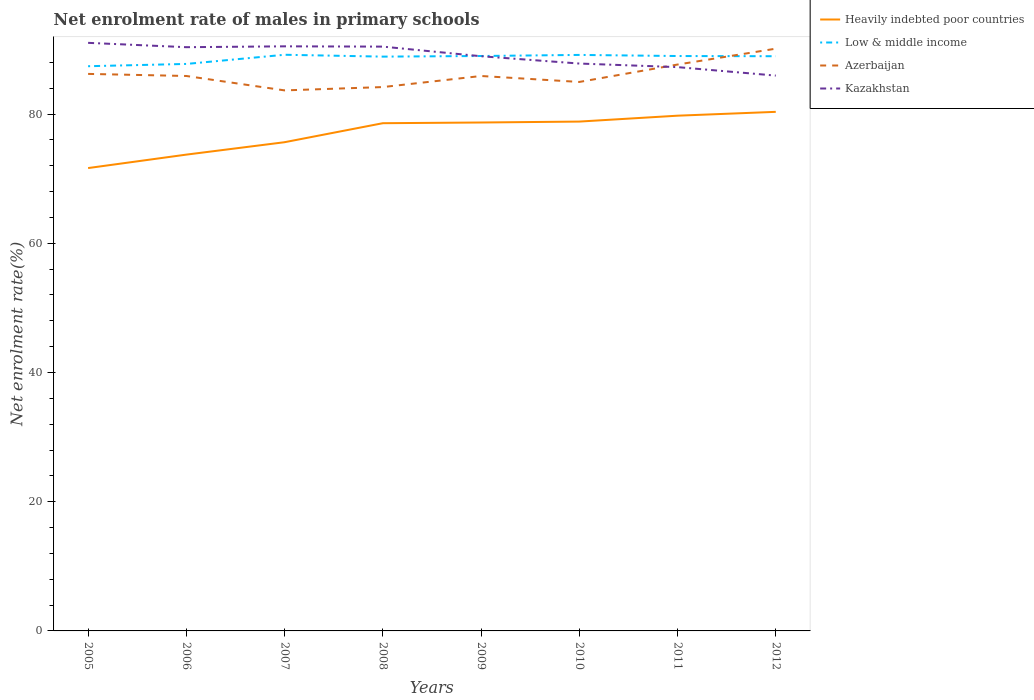How many different coloured lines are there?
Offer a very short reply. 4. Is the number of lines equal to the number of legend labels?
Keep it short and to the point. Yes. Across all years, what is the maximum net enrolment rate of males in primary schools in Azerbaijan?
Your response must be concise. 83.67. In which year was the net enrolment rate of males in primary schools in Kazakhstan maximum?
Your answer should be very brief. 2012. What is the total net enrolment rate of males in primary schools in Kazakhstan in the graph?
Make the answer very short. -0.13. What is the difference between the highest and the second highest net enrolment rate of males in primary schools in Heavily indebted poor countries?
Offer a very short reply. 8.7. What is the difference between the highest and the lowest net enrolment rate of males in primary schools in Kazakhstan?
Offer a very short reply. 4. Is the net enrolment rate of males in primary schools in Low & middle income strictly greater than the net enrolment rate of males in primary schools in Azerbaijan over the years?
Your answer should be compact. No. How many lines are there?
Offer a terse response. 4. How many years are there in the graph?
Keep it short and to the point. 8. What is the difference between two consecutive major ticks on the Y-axis?
Make the answer very short. 20. Are the values on the major ticks of Y-axis written in scientific E-notation?
Provide a succinct answer. No. Does the graph contain any zero values?
Ensure brevity in your answer.  No. How many legend labels are there?
Make the answer very short. 4. What is the title of the graph?
Provide a succinct answer. Net enrolment rate of males in primary schools. Does "Cyprus" appear as one of the legend labels in the graph?
Provide a short and direct response. No. What is the label or title of the Y-axis?
Your answer should be compact. Net enrolment rate(%). What is the Net enrolment rate(%) in Heavily indebted poor countries in 2005?
Your response must be concise. 71.64. What is the Net enrolment rate(%) in Low & middle income in 2005?
Your answer should be compact. 87.41. What is the Net enrolment rate(%) in Azerbaijan in 2005?
Keep it short and to the point. 86.22. What is the Net enrolment rate(%) in Kazakhstan in 2005?
Provide a succinct answer. 91.03. What is the Net enrolment rate(%) in Heavily indebted poor countries in 2006?
Your answer should be very brief. 73.72. What is the Net enrolment rate(%) in Low & middle income in 2006?
Keep it short and to the point. 87.76. What is the Net enrolment rate(%) in Azerbaijan in 2006?
Provide a short and direct response. 85.89. What is the Net enrolment rate(%) in Kazakhstan in 2006?
Provide a succinct answer. 90.35. What is the Net enrolment rate(%) of Heavily indebted poor countries in 2007?
Your response must be concise. 75.65. What is the Net enrolment rate(%) in Low & middle income in 2007?
Ensure brevity in your answer.  89.18. What is the Net enrolment rate(%) in Azerbaijan in 2007?
Your answer should be very brief. 83.67. What is the Net enrolment rate(%) in Kazakhstan in 2007?
Ensure brevity in your answer.  90.48. What is the Net enrolment rate(%) in Heavily indebted poor countries in 2008?
Offer a very short reply. 78.59. What is the Net enrolment rate(%) in Low & middle income in 2008?
Make the answer very short. 88.89. What is the Net enrolment rate(%) of Azerbaijan in 2008?
Keep it short and to the point. 84.18. What is the Net enrolment rate(%) in Kazakhstan in 2008?
Offer a terse response. 90.44. What is the Net enrolment rate(%) of Heavily indebted poor countries in 2009?
Ensure brevity in your answer.  78.7. What is the Net enrolment rate(%) of Low & middle income in 2009?
Keep it short and to the point. 88.99. What is the Net enrolment rate(%) in Azerbaijan in 2009?
Your response must be concise. 85.89. What is the Net enrolment rate(%) in Kazakhstan in 2009?
Offer a very short reply. 88.95. What is the Net enrolment rate(%) in Heavily indebted poor countries in 2010?
Your response must be concise. 78.84. What is the Net enrolment rate(%) in Low & middle income in 2010?
Your answer should be compact. 89.16. What is the Net enrolment rate(%) in Azerbaijan in 2010?
Offer a very short reply. 84.97. What is the Net enrolment rate(%) in Kazakhstan in 2010?
Provide a short and direct response. 87.82. What is the Net enrolment rate(%) in Heavily indebted poor countries in 2011?
Your answer should be compact. 79.75. What is the Net enrolment rate(%) of Low & middle income in 2011?
Your answer should be very brief. 88.98. What is the Net enrolment rate(%) in Azerbaijan in 2011?
Offer a terse response. 87.66. What is the Net enrolment rate(%) of Kazakhstan in 2011?
Your answer should be compact. 87.27. What is the Net enrolment rate(%) in Heavily indebted poor countries in 2012?
Ensure brevity in your answer.  80.34. What is the Net enrolment rate(%) of Low & middle income in 2012?
Provide a short and direct response. 88.95. What is the Net enrolment rate(%) in Azerbaijan in 2012?
Provide a short and direct response. 90.12. What is the Net enrolment rate(%) in Kazakhstan in 2012?
Give a very brief answer. 85.96. Across all years, what is the maximum Net enrolment rate(%) in Heavily indebted poor countries?
Make the answer very short. 80.34. Across all years, what is the maximum Net enrolment rate(%) in Low & middle income?
Give a very brief answer. 89.18. Across all years, what is the maximum Net enrolment rate(%) of Azerbaijan?
Offer a very short reply. 90.12. Across all years, what is the maximum Net enrolment rate(%) in Kazakhstan?
Make the answer very short. 91.03. Across all years, what is the minimum Net enrolment rate(%) of Heavily indebted poor countries?
Ensure brevity in your answer.  71.64. Across all years, what is the minimum Net enrolment rate(%) of Low & middle income?
Keep it short and to the point. 87.41. Across all years, what is the minimum Net enrolment rate(%) in Azerbaijan?
Ensure brevity in your answer.  83.67. Across all years, what is the minimum Net enrolment rate(%) of Kazakhstan?
Ensure brevity in your answer.  85.96. What is the total Net enrolment rate(%) of Heavily indebted poor countries in the graph?
Your answer should be very brief. 617.22. What is the total Net enrolment rate(%) of Low & middle income in the graph?
Your answer should be very brief. 709.32. What is the total Net enrolment rate(%) in Azerbaijan in the graph?
Your answer should be compact. 688.61. What is the total Net enrolment rate(%) in Kazakhstan in the graph?
Make the answer very short. 712.3. What is the difference between the Net enrolment rate(%) of Heavily indebted poor countries in 2005 and that in 2006?
Provide a short and direct response. -2.08. What is the difference between the Net enrolment rate(%) in Low & middle income in 2005 and that in 2006?
Your answer should be compact. -0.35. What is the difference between the Net enrolment rate(%) of Azerbaijan in 2005 and that in 2006?
Your response must be concise. 0.32. What is the difference between the Net enrolment rate(%) in Kazakhstan in 2005 and that in 2006?
Provide a succinct answer. 0.67. What is the difference between the Net enrolment rate(%) of Heavily indebted poor countries in 2005 and that in 2007?
Your response must be concise. -4. What is the difference between the Net enrolment rate(%) of Low & middle income in 2005 and that in 2007?
Your response must be concise. -1.77. What is the difference between the Net enrolment rate(%) in Azerbaijan in 2005 and that in 2007?
Keep it short and to the point. 2.55. What is the difference between the Net enrolment rate(%) of Kazakhstan in 2005 and that in 2007?
Ensure brevity in your answer.  0.54. What is the difference between the Net enrolment rate(%) in Heavily indebted poor countries in 2005 and that in 2008?
Offer a very short reply. -6.95. What is the difference between the Net enrolment rate(%) in Low & middle income in 2005 and that in 2008?
Keep it short and to the point. -1.49. What is the difference between the Net enrolment rate(%) of Azerbaijan in 2005 and that in 2008?
Keep it short and to the point. 2.04. What is the difference between the Net enrolment rate(%) in Kazakhstan in 2005 and that in 2008?
Provide a succinct answer. 0.59. What is the difference between the Net enrolment rate(%) in Heavily indebted poor countries in 2005 and that in 2009?
Your response must be concise. -7.05. What is the difference between the Net enrolment rate(%) of Low & middle income in 2005 and that in 2009?
Your answer should be very brief. -1.58. What is the difference between the Net enrolment rate(%) in Azerbaijan in 2005 and that in 2009?
Offer a terse response. 0.32. What is the difference between the Net enrolment rate(%) in Kazakhstan in 2005 and that in 2009?
Provide a succinct answer. 2.07. What is the difference between the Net enrolment rate(%) in Heavily indebted poor countries in 2005 and that in 2010?
Keep it short and to the point. -7.2. What is the difference between the Net enrolment rate(%) of Low & middle income in 2005 and that in 2010?
Offer a terse response. -1.75. What is the difference between the Net enrolment rate(%) in Azerbaijan in 2005 and that in 2010?
Give a very brief answer. 1.25. What is the difference between the Net enrolment rate(%) of Kazakhstan in 2005 and that in 2010?
Your answer should be very brief. 3.21. What is the difference between the Net enrolment rate(%) in Heavily indebted poor countries in 2005 and that in 2011?
Provide a short and direct response. -8.11. What is the difference between the Net enrolment rate(%) in Low & middle income in 2005 and that in 2011?
Your response must be concise. -1.58. What is the difference between the Net enrolment rate(%) in Azerbaijan in 2005 and that in 2011?
Keep it short and to the point. -1.45. What is the difference between the Net enrolment rate(%) of Kazakhstan in 2005 and that in 2011?
Ensure brevity in your answer.  3.76. What is the difference between the Net enrolment rate(%) of Heavily indebted poor countries in 2005 and that in 2012?
Your answer should be compact. -8.7. What is the difference between the Net enrolment rate(%) of Low & middle income in 2005 and that in 2012?
Ensure brevity in your answer.  -1.55. What is the difference between the Net enrolment rate(%) of Azerbaijan in 2005 and that in 2012?
Provide a short and direct response. -3.9. What is the difference between the Net enrolment rate(%) in Kazakhstan in 2005 and that in 2012?
Provide a succinct answer. 5.07. What is the difference between the Net enrolment rate(%) in Heavily indebted poor countries in 2006 and that in 2007?
Give a very brief answer. -1.92. What is the difference between the Net enrolment rate(%) of Low & middle income in 2006 and that in 2007?
Give a very brief answer. -1.42. What is the difference between the Net enrolment rate(%) in Azerbaijan in 2006 and that in 2007?
Provide a succinct answer. 2.23. What is the difference between the Net enrolment rate(%) of Kazakhstan in 2006 and that in 2007?
Provide a succinct answer. -0.13. What is the difference between the Net enrolment rate(%) of Heavily indebted poor countries in 2006 and that in 2008?
Offer a very short reply. -4.86. What is the difference between the Net enrolment rate(%) of Low & middle income in 2006 and that in 2008?
Offer a terse response. -1.13. What is the difference between the Net enrolment rate(%) in Azerbaijan in 2006 and that in 2008?
Give a very brief answer. 1.71. What is the difference between the Net enrolment rate(%) in Kazakhstan in 2006 and that in 2008?
Keep it short and to the point. -0.09. What is the difference between the Net enrolment rate(%) of Heavily indebted poor countries in 2006 and that in 2009?
Your answer should be compact. -4.97. What is the difference between the Net enrolment rate(%) in Low & middle income in 2006 and that in 2009?
Your response must be concise. -1.23. What is the difference between the Net enrolment rate(%) of Azerbaijan in 2006 and that in 2009?
Your answer should be compact. 0. What is the difference between the Net enrolment rate(%) of Kazakhstan in 2006 and that in 2009?
Offer a very short reply. 1.4. What is the difference between the Net enrolment rate(%) in Heavily indebted poor countries in 2006 and that in 2010?
Your response must be concise. -5.11. What is the difference between the Net enrolment rate(%) of Low & middle income in 2006 and that in 2010?
Make the answer very short. -1.4. What is the difference between the Net enrolment rate(%) of Azerbaijan in 2006 and that in 2010?
Your answer should be very brief. 0.92. What is the difference between the Net enrolment rate(%) in Kazakhstan in 2006 and that in 2010?
Ensure brevity in your answer.  2.53. What is the difference between the Net enrolment rate(%) of Heavily indebted poor countries in 2006 and that in 2011?
Offer a terse response. -6.03. What is the difference between the Net enrolment rate(%) in Low & middle income in 2006 and that in 2011?
Provide a succinct answer. -1.22. What is the difference between the Net enrolment rate(%) of Azerbaijan in 2006 and that in 2011?
Give a very brief answer. -1.77. What is the difference between the Net enrolment rate(%) of Kazakhstan in 2006 and that in 2011?
Keep it short and to the point. 3.09. What is the difference between the Net enrolment rate(%) of Heavily indebted poor countries in 2006 and that in 2012?
Give a very brief answer. -6.62. What is the difference between the Net enrolment rate(%) in Low & middle income in 2006 and that in 2012?
Offer a terse response. -1.19. What is the difference between the Net enrolment rate(%) in Azerbaijan in 2006 and that in 2012?
Your answer should be very brief. -4.23. What is the difference between the Net enrolment rate(%) in Kazakhstan in 2006 and that in 2012?
Your answer should be compact. 4.4. What is the difference between the Net enrolment rate(%) of Heavily indebted poor countries in 2007 and that in 2008?
Offer a very short reply. -2.94. What is the difference between the Net enrolment rate(%) in Low & middle income in 2007 and that in 2008?
Give a very brief answer. 0.29. What is the difference between the Net enrolment rate(%) in Azerbaijan in 2007 and that in 2008?
Your answer should be compact. -0.51. What is the difference between the Net enrolment rate(%) in Kazakhstan in 2007 and that in 2008?
Keep it short and to the point. 0.04. What is the difference between the Net enrolment rate(%) of Heavily indebted poor countries in 2007 and that in 2009?
Ensure brevity in your answer.  -3.05. What is the difference between the Net enrolment rate(%) of Low & middle income in 2007 and that in 2009?
Your answer should be very brief. 0.19. What is the difference between the Net enrolment rate(%) of Azerbaijan in 2007 and that in 2009?
Provide a short and direct response. -2.23. What is the difference between the Net enrolment rate(%) in Kazakhstan in 2007 and that in 2009?
Your response must be concise. 1.53. What is the difference between the Net enrolment rate(%) of Heavily indebted poor countries in 2007 and that in 2010?
Your answer should be very brief. -3.19. What is the difference between the Net enrolment rate(%) in Low & middle income in 2007 and that in 2010?
Your answer should be compact. 0.02. What is the difference between the Net enrolment rate(%) of Azerbaijan in 2007 and that in 2010?
Your response must be concise. -1.31. What is the difference between the Net enrolment rate(%) of Kazakhstan in 2007 and that in 2010?
Ensure brevity in your answer.  2.66. What is the difference between the Net enrolment rate(%) in Heavily indebted poor countries in 2007 and that in 2011?
Make the answer very short. -4.1. What is the difference between the Net enrolment rate(%) in Low & middle income in 2007 and that in 2011?
Keep it short and to the point. 0.2. What is the difference between the Net enrolment rate(%) in Azerbaijan in 2007 and that in 2011?
Ensure brevity in your answer.  -4. What is the difference between the Net enrolment rate(%) of Kazakhstan in 2007 and that in 2011?
Make the answer very short. 3.22. What is the difference between the Net enrolment rate(%) of Heavily indebted poor countries in 2007 and that in 2012?
Provide a succinct answer. -4.7. What is the difference between the Net enrolment rate(%) of Low & middle income in 2007 and that in 2012?
Make the answer very short. 0.23. What is the difference between the Net enrolment rate(%) of Azerbaijan in 2007 and that in 2012?
Keep it short and to the point. -6.46. What is the difference between the Net enrolment rate(%) of Kazakhstan in 2007 and that in 2012?
Give a very brief answer. 4.53. What is the difference between the Net enrolment rate(%) in Heavily indebted poor countries in 2008 and that in 2009?
Give a very brief answer. -0.11. What is the difference between the Net enrolment rate(%) of Low & middle income in 2008 and that in 2009?
Make the answer very short. -0.1. What is the difference between the Net enrolment rate(%) of Azerbaijan in 2008 and that in 2009?
Provide a succinct answer. -1.71. What is the difference between the Net enrolment rate(%) of Kazakhstan in 2008 and that in 2009?
Offer a terse response. 1.49. What is the difference between the Net enrolment rate(%) of Heavily indebted poor countries in 2008 and that in 2010?
Your answer should be compact. -0.25. What is the difference between the Net enrolment rate(%) of Low & middle income in 2008 and that in 2010?
Provide a short and direct response. -0.26. What is the difference between the Net enrolment rate(%) of Azerbaijan in 2008 and that in 2010?
Your response must be concise. -0.79. What is the difference between the Net enrolment rate(%) of Kazakhstan in 2008 and that in 2010?
Give a very brief answer. 2.62. What is the difference between the Net enrolment rate(%) of Heavily indebted poor countries in 2008 and that in 2011?
Provide a succinct answer. -1.16. What is the difference between the Net enrolment rate(%) in Low & middle income in 2008 and that in 2011?
Your answer should be compact. -0.09. What is the difference between the Net enrolment rate(%) in Azerbaijan in 2008 and that in 2011?
Provide a short and direct response. -3.48. What is the difference between the Net enrolment rate(%) of Kazakhstan in 2008 and that in 2011?
Your response must be concise. 3.17. What is the difference between the Net enrolment rate(%) in Heavily indebted poor countries in 2008 and that in 2012?
Offer a terse response. -1.76. What is the difference between the Net enrolment rate(%) in Low & middle income in 2008 and that in 2012?
Your response must be concise. -0.06. What is the difference between the Net enrolment rate(%) of Azerbaijan in 2008 and that in 2012?
Make the answer very short. -5.94. What is the difference between the Net enrolment rate(%) in Kazakhstan in 2008 and that in 2012?
Provide a succinct answer. 4.49. What is the difference between the Net enrolment rate(%) of Heavily indebted poor countries in 2009 and that in 2010?
Keep it short and to the point. -0.14. What is the difference between the Net enrolment rate(%) of Low & middle income in 2009 and that in 2010?
Provide a short and direct response. -0.17. What is the difference between the Net enrolment rate(%) of Azerbaijan in 2009 and that in 2010?
Provide a short and direct response. 0.92. What is the difference between the Net enrolment rate(%) in Kazakhstan in 2009 and that in 2010?
Give a very brief answer. 1.13. What is the difference between the Net enrolment rate(%) of Heavily indebted poor countries in 2009 and that in 2011?
Offer a very short reply. -1.05. What is the difference between the Net enrolment rate(%) in Low & middle income in 2009 and that in 2011?
Ensure brevity in your answer.  0. What is the difference between the Net enrolment rate(%) in Azerbaijan in 2009 and that in 2011?
Provide a succinct answer. -1.77. What is the difference between the Net enrolment rate(%) of Kazakhstan in 2009 and that in 2011?
Provide a succinct answer. 1.69. What is the difference between the Net enrolment rate(%) in Heavily indebted poor countries in 2009 and that in 2012?
Provide a succinct answer. -1.65. What is the difference between the Net enrolment rate(%) in Low & middle income in 2009 and that in 2012?
Make the answer very short. 0.03. What is the difference between the Net enrolment rate(%) in Azerbaijan in 2009 and that in 2012?
Your response must be concise. -4.23. What is the difference between the Net enrolment rate(%) in Kazakhstan in 2009 and that in 2012?
Offer a terse response. 3. What is the difference between the Net enrolment rate(%) of Heavily indebted poor countries in 2010 and that in 2011?
Your answer should be compact. -0.91. What is the difference between the Net enrolment rate(%) of Low & middle income in 2010 and that in 2011?
Offer a terse response. 0.17. What is the difference between the Net enrolment rate(%) of Azerbaijan in 2010 and that in 2011?
Your answer should be compact. -2.69. What is the difference between the Net enrolment rate(%) in Kazakhstan in 2010 and that in 2011?
Your answer should be compact. 0.55. What is the difference between the Net enrolment rate(%) of Heavily indebted poor countries in 2010 and that in 2012?
Provide a succinct answer. -1.51. What is the difference between the Net enrolment rate(%) of Low & middle income in 2010 and that in 2012?
Keep it short and to the point. 0.2. What is the difference between the Net enrolment rate(%) of Azerbaijan in 2010 and that in 2012?
Make the answer very short. -5.15. What is the difference between the Net enrolment rate(%) in Kazakhstan in 2010 and that in 2012?
Your response must be concise. 1.86. What is the difference between the Net enrolment rate(%) of Heavily indebted poor countries in 2011 and that in 2012?
Your answer should be compact. -0.6. What is the difference between the Net enrolment rate(%) of Low & middle income in 2011 and that in 2012?
Your response must be concise. 0.03. What is the difference between the Net enrolment rate(%) in Azerbaijan in 2011 and that in 2012?
Ensure brevity in your answer.  -2.46. What is the difference between the Net enrolment rate(%) in Kazakhstan in 2011 and that in 2012?
Keep it short and to the point. 1.31. What is the difference between the Net enrolment rate(%) in Heavily indebted poor countries in 2005 and the Net enrolment rate(%) in Low & middle income in 2006?
Offer a terse response. -16.12. What is the difference between the Net enrolment rate(%) of Heavily indebted poor countries in 2005 and the Net enrolment rate(%) of Azerbaijan in 2006?
Give a very brief answer. -14.25. What is the difference between the Net enrolment rate(%) in Heavily indebted poor countries in 2005 and the Net enrolment rate(%) in Kazakhstan in 2006?
Give a very brief answer. -18.71. What is the difference between the Net enrolment rate(%) in Low & middle income in 2005 and the Net enrolment rate(%) in Azerbaijan in 2006?
Offer a very short reply. 1.51. What is the difference between the Net enrolment rate(%) of Low & middle income in 2005 and the Net enrolment rate(%) of Kazakhstan in 2006?
Give a very brief answer. -2.94. What is the difference between the Net enrolment rate(%) in Azerbaijan in 2005 and the Net enrolment rate(%) in Kazakhstan in 2006?
Offer a very short reply. -4.13. What is the difference between the Net enrolment rate(%) of Heavily indebted poor countries in 2005 and the Net enrolment rate(%) of Low & middle income in 2007?
Your answer should be very brief. -17.54. What is the difference between the Net enrolment rate(%) in Heavily indebted poor countries in 2005 and the Net enrolment rate(%) in Azerbaijan in 2007?
Offer a terse response. -12.02. What is the difference between the Net enrolment rate(%) in Heavily indebted poor countries in 2005 and the Net enrolment rate(%) in Kazakhstan in 2007?
Offer a very short reply. -18.84. What is the difference between the Net enrolment rate(%) of Low & middle income in 2005 and the Net enrolment rate(%) of Azerbaijan in 2007?
Your answer should be compact. 3.74. What is the difference between the Net enrolment rate(%) of Low & middle income in 2005 and the Net enrolment rate(%) of Kazakhstan in 2007?
Make the answer very short. -3.08. What is the difference between the Net enrolment rate(%) of Azerbaijan in 2005 and the Net enrolment rate(%) of Kazakhstan in 2007?
Offer a terse response. -4.27. What is the difference between the Net enrolment rate(%) of Heavily indebted poor countries in 2005 and the Net enrolment rate(%) of Low & middle income in 2008?
Your answer should be very brief. -17.25. What is the difference between the Net enrolment rate(%) in Heavily indebted poor countries in 2005 and the Net enrolment rate(%) in Azerbaijan in 2008?
Make the answer very short. -12.54. What is the difference between the Net enrolment rate(%) in Heavily indebted poor countries in 2005 and the Net enrolment rate(%) in Kazakhstan in 2008?
Ensure brevity in your answer.  -18.8. What is the difference between the Net enrolment rate(%) of Low & middle income in 2005 and the Net enrolment rate(%) of Azerbaijan in 2008?
Your answer should be very brief. 3.23. What is the difference between the Net enrolment rate(%) of Low & middle income in 2005 and the Net enrolment rate(%) of Kazakhstan in 2008?
Offer a terse response. -3.03. What is the difference between the Net enrolment rate(%) of Azerbaijan in 2005 and the Net enrolment rate(%) of Kazakhstan in 2008?
Keep it short and to the point. -4.22. What is the difference between the Net enrolment rate(%) in Heavily indebted poor countries in 2005 and the Net enrolment rate(%) in Low & middle income in 2009?
Keep it short and to the point. -17.35. What is the difference between the Net enrolment rate(%) in Heavily indebted poor countries in 2005 and the Net enrolment rate(%) in Azerbaijan in 2009?
Provide a succinct answer. -14.25. What is the difference between the Net enrolment rate(%) in Heavily indebted poor countries in 2005 and the Net enrolment rate(%) in Kazakhstan in 2009?
Your answer should be very brief. -17.31. What is the difference between the Net enrolment rate(%) in Low & middle income in 2005 and the Net enrolment rate(%) in Azerbaijan in 2009?
Ensure brevity in your answer.  1.51. What is the difference between the Net enrolment rate(%) of Low & middle income in 2005 and the Net enrolment rate(%) of Kazakhstan in 2009?
Make the answer very short. -1.55. What is the difference between the Net enrolment rate(%) of Azerbaijan in 2005 and the Net enrolment rate(%) of Kazakhstan in 2009?
Provide a short and direct response. -2.73. What is the difference between the Net enrolment rate(%) of Heavily indebted poor countries in 2005 and the Net enrolment rate(%) of Low & middle income in 2010?
Your response must be concise. -17.51. What is the difference between the Net enrolment rate(%) in Heavily indebted poor countries in 2005 and the Net enrolment rate(%) in Azerbaijan in 2010?
Provide a short and direct response. -13.33. What is the difference between the Net enrolment rate(%) of Heavily indebted poor countries in 2005 and the Net enrolment rate(%) of Kazakhstan in 2010?
Make the answer very short. -16.18. What is the difference between the Net enrolment rate(%) of Low & middle income in 2005 and the Net enrolment rate(%) of Azerbaijan in 2010?
Give a very brief answer. 2.44. What is the difference between the Net enrolment rate(%) in Low & middle income in 2005 and the Net enrolment rate(%) in Kazakhstan in 2010?
Keep it short and to the point. -0.41. What is the difference between the Net enrolment rate(%) of Azerbaijan in 2005 and the Net enrolment rate(%) of Kazakhstan in 2010?
Your answer should be very brief. -1.6. What is the difference between the Net enrolment rate(%) in Heavily indebted poor countries in 2005 and the Net enrolment rate(%) in Low & middle income in 2011?
Your answer should be compact. -17.34. What is the difference between the Net enrolment rate(%) of Heavily indebted poor countries in 2005 and the Net enrolment rate(%) of Azerbaijan in 2011?
Your answer should be very brief. -16.02. What is the difference between the Net enrolment rate(%) of Heavily indebted poor countries in 2005 and the Net enrolment rate(%) of Kazakhstan in 2011?
Make the answer very short. -15.63. What is the difference between the Net enrolment rate(%) in Low & middle income in 2005 and the Net enrolment rate(%) in Azerbaijan in 2011?
Give a very brief answer. -0.26. What is the difference between the Net enrolment rate(%) of Low & middle income in 2005 and the Net enrolment rate(%) of Kazakhstan in 2011?
Make the answer very short. 0.14. What is the difference between the Net enrolment rate(%) of Azerbaijan in 2005 and the Net enrolment rate(%) of Kazakhstan in 2011?
Your answer should be compact. -1.05. What is the difference between the Net enrolment rate(%) in Heavily indebted poor countries in 2005 and the Net enrolment rate(%) in Low & middle income in 2012?
Provide a succinct answer. -17.31. What is the difference between the Net enrolment rate(%) of Heavily indebted poor countries in 2005 and the Net enrolment rate(%) of Azerbaijan in 2012?
Make the answer very short. -18.48. What is the difference between the Net enrolment rate(%) of Heavily indebted poor countries in 2005 and the Net enrolment rate(%) of Kazakhstan in 2012?
Your response must be concise. -14.31. What is the difference between the Net enrolment rate(%) of Low & middle income in 2005 and the Net enrolment rate(%) of Azerbaijan in 2012?
Your answer should be compact. -2.72. What is the difference between the Net enrolment rate(%) of Low & middle income in 2005 and the Net enrolment rate(%) of Kazakhstan in 2012?
Ensure brevity in your answer.  1.45. What is the difference between the Net enrolment rate(%) of Azerbaijan in 2005 and the Net enrolment rate(%) of Kazakhstan in 2012?
Make the answer very short. 0.26. What is the difference between the Net enrolment rate(%) in Heavily indebted poor countries in 2006 and the Net enrolment rate(%) in Low & middle income in 2007?
Make the answer very short. -15.46. What is the difference between the Net enrolment rate(%) in Heavily indebted poor countries in 2006 and the Net enrolment rate(%) in Azerbaijan in 2007?
Your answer should be very brief. -9.94. What is the difference between the Net enrolment rate(%) in Heavily indebted poor countries in 2006 and the Net enrolment rate(%) in Kazakhstan in 2007?
Keep it short and to the point. -16.76. What is the difference between the Net enrolment rate(%) in Low & middle income in 2006 and the Net enrolment rate(%) in Azerbaijan in 2007?
Provide a short and direct response. 4.09. What is the difference between the Net enrolment rate(%) in Low & middle income in 2006 and the Net enrolment rate(%) in Kazakhstan in 2007?
Offer a very short reply. -2.73. What is the difference between the Net enrolment rate(%) in Azerbaijan in 2006 and the Net enrolment rate(%) in Kazakhstan in 2007?
Offer a very short reply. -4.59. What is the difference between the Net enrolment rate(%) in Heavily indebted poor countries in 2006 and the Net enrolment rate(%) in Low & middle income in 2008?
Your answer should be very brief. -15.17. What is the difference between the Net enrolment rate(%) in Heavily indebted poor countries in 2006 and the Net enrolment rate(%) in Azerbaijan in 2008?
Keep it short and to the point. -10.46. What is the difference between the Net enrolment rate(%) in Heavily indebted poor countries in 2006 and the Net enrolment rate(%) in Kazakhstan in 2008?
Offer a very short reply. -16.72. What is the difference between the Net enrolment rate(%) of Low & middle income in 2006 and the Net enrolment rate(%) of Azerbaijan in 2008?
Offer a terse response. 3.58. What is the difference between the Net enrolment rate(%) in Low & middle income in 2006 and the Net enrolment rate(%) in Kazakhstan in 2008?
Offer a very short reply. -2.68. What is the difference between the Net enrolment rate(%) in Azerbaijan in 2006 and the Net enrolment rate(%) in Kazakhstan in 2008?
Offer a very short reply. -4.55. What is the difference between the Net enrolment rate(%) of Heavily indebted poor countries in 2006 and the Net enrolment rate(%) of Low & middle income in 2009?
Provide a short and direct response. -15.26. What is the difference between the Net enrolment rate(%) in Heavily indebted poor countries in 2006 and the Net enrolment rate(%) in Azerbaijan in 2009?
Provide a short and direct response. -12.17. What is the difference between the Net enrolment rate(%) in Heavily indebted poor countries in 2006 and the Net enrolment rate(%) in Kazakhstan in 2009?
Your answer should be compact. -15.23. What is the difference between the Net enrolment rate(%) in Low & middle income in 2006 and the Net enrolment rate(%) in Azerbaijan in 2009?
Your answer should be compact. 1.87. What is the difference between the Net enrolment rate(%) of Low & middle income in 2006 and the Net enrolment rate(%) of Kazakhstan in 2009?
Offer a very short reply. -1.19. What is the difference between the Net enrolment rate(%) of Azerbaijan in 2006 and the Net enrolment rate(%) of Kazakhstan in 2009?
Keep it short and to the point. -3.06. What is the difference between the Net enrolment rate(%) in Heavily indebted poor countries in 2006 and the Net enrolment rate(%) in Low & middle income in 2010?
Your answer should be very brief. -15.43. What is the difference between the Net enrolment rate(%) in Heavily indebted poor countries in 2006 and the Net enrolment rate(%) in Azerbaijan in 2010?
Ensure brevity in your answer.  -11.25. What is the difference between the Net enrolment rate(%) of Heavily indebted poor countries in 2006 and the Net enrolment rate(%) of Kazakhstan in 2010?
Provide a short and direct response. -14.1. What is the difference between the Net enrolment rate(%) of Low & middle income in 2006 and the Net enrolment rate(%) of Azerbaijan in 2010?
Keep it short and to the point. 2.79. What is the difference between the Net enrolment rate(%) of Low & middle income in 2006 and the Net enrolment rate(%) of Kazakhstan in 2010?
Your response must be concise. -0.06. What is the difference between the Net enrolment rate(%) of Azerbaijan in 2006 and the Net enrolment rate(%) of Kazakhstan in 2010?
Offer a terse response. -1.93. What is the difference between the Net enrolment rate(%) of Heavily indebted poor countries in 2006 and the Net enrolment rate(%) of Low & middle income in 2011?
Offer a very short reply. -15.26. What is the difference between the Net enrolment rate(%) in Heavily indebted poor countries in 2006 and the Net enrolment rate(%) in Azerbaijan in 2011?
Your response must be concise. -13.94. What is the difference between the Net enrolment rate(%) in Heavily indebted poor countries in 2006 and the Net enrolment rate(%) in Kazakhstan in 2011?
Provide a short and direct response. -13.54. What is the difference between the Net enrolment rate(%) in Low & middle income in 2006 and the Net enrolment rate(%) in Azerbaijan in 2011?
Your response must be concise. 0.09. What is the difference between the Net enrolment rate(%) of Low & middle income in 2006 and the Net enrolment rate(%) of Kazakhstan in 2011?
Ensure brevity in your answer.  0.49. What is the difference between the Net enrolment rate(%) in Azerbaijan in 2006 and the Net enrolment rate(%) in Kazakhstan in 2011?
Offer a very short reply. -1.37. What is the difference between the Net enrolment rate(%) of Heavily indebted poor countries in 2006 and the Net enrolment rate(%) of Low & middle income in 2012?
Offer a very short reply. -15.23. What is the difference between the Net enrolment rate(%) in Heavily indebted poor countries in 2006 and the Net enrolment rate(%) in Azerbaijan in 2012?
Your response must be concise. -16.4. What is the difference between the Net enrolment rate(%) of Heavily indebted poor countries in 2006 and the Net enrolment rate(%) of Kazakhstan in 2012?
Give a very brief answer. -12.23. What is the difference between the Net enrolment rate(%) of Low & middle income in 2006 and the Net enrolment rate(%) of Azerbaijan in 2012?
Keep it short and to the point. -2.36. What is the difference between the Net enrolment rate(%) of Low & middle income in 2006 and the Net enrolment rate(%) of Kazakhstan in 2012?
Your response must be concise. 1.8. What is the difference between the Net enrolment rate(%) of Azerbaijan in 2006 and the Net enrolment rate(%) of Kazakhstan in 2012?
Keep it short and to the point. -0.06. What is the difference between the Net enrolment rate(%) of Heavily indebted poor countries in 2007 and the Net enrolment rate(%) of Low & middle income in 2008?
Offer a terse response. -13.25. What is the difference between the Net enrolment rate(%) in Heavily indebted poor countries in 2007 and the Net enrolment rate(%) in Azerbaijan in 2008?
Ensure brevity in your answer.  -8.54. What is the difference between the Net enrolment rate(%) in Heavily indebted poor countries in 2007 and the Net enrolment rate(%) in Kazakhstan in 2008?
Ensure brevity in your answer.  -14.8. What is the difference between the Net enrolment rate(%) of Low & middle income in 2007 and the Net enrolment rate(%) of Azerbaijan in 2008?
Your answer should be compact. 5. What is the difference between the Net enrolment rate(%) in Low & middle income in 2007 and the Net enrolment rate(%) in Kazakhstan in 2008?
Make the answer very short. -1.26. What is the difference between the Net enrolment rate(%) in Azerbaijan in 2007 and the Net enrolment rate(%) in Kazakhstan in 2008?
Provide a short and direct response. -6.77. What is the difference between the Net enrolment rate(%) in Heavily indebted poor countries in 2007 and the Net enrolment rate(%) in Low & middle income in 2009?
Make the answer very short. -13.34. What is the difference between the Net enrolment rate(%) in Heavily indebted poor countries in 2007 and the Net enrolment rate(%) in Azerbaijan in 2009?
Offer a very short reply. -10.25. What is the difference between the Net enrolment rate(%) of Heavily indebted poor countries in 2007 and the Net enrolment rate(%) of Kazakhstan in 2009?
Offer a terse response. -13.31. What is the difference between the Net enrolment rate(%) of Low & middle income in 2007 and the Net enrolment rate(%) of Azerbaijan in 2009?
Ensure brevity in your answer.  3.29. What is the difference between the Net enrolment rate(%) of Low & middle income in 2007 and the Net enrolment rate(%) of Kazakhstan in 2009?
Make the answer very short. 0.23. What is the difference between the Net enrolment rate(%) in Azerbaijan in 2007 and the Net enrolment rate(%) in Kazakhstan in 2009?
Provide a short and direct response. -5.29. What is the difference between the Net enrolment rate(%) in Heavily indebted poor countries in 2007 and the Net enrolment rate(%) in Low & middle income in 2010?
Provide a short and direct response. -13.51. What is the difference between the Net enrolment rate(%) in Heavily indebted poor countries in 2007 and the Net enrolment rate(%) in Azerbaijan in 2010?
Keep it short and to the point. -9.33. What is the difference between the Net enrolment rate(%) in Heavily indebted poor countries in 2007 and the Net enrolment rate(%) in Kazakhstan in 2010?
Keep it short and to the point. -12.17. What is the difference between the Net enrolment rate(%) in Low & middle income in 2007 and the Net enrolment rate(%) in Azerbaijan in 2010?
Your response must be concise. 4.21. What is the difference between the Net enrolment rate(%) of Low & middle income in 2007 and the Net enrolment rate(%) of Kazakhstan in 2010?
Your answer should be compact. 1.36. What is the difference between the Net enrolment rate(%) of Azerbaijan in 2007 and the Net enrolment rate(%) of Kazakhstan in 2010?
Your response must be concise. -4.15. What is the difference between the Net enrolment rate(%) of Heavily indebted poor countries in 2007 and the Net enrolment rate(%) of Low & middle income in 2011?
Provide a short and direct response. -13.34. What is the difference between the Net enrolment rate(%) of Heavily indebted poor countries in 2007 and the Net enrolment rate(%) of Azerbaijan in 2011?
Your response must be concise. -12.02. What is the difference between the Net enrolment rate(%) in Heavily indebted poor countries in 2007 and the Net enrolment rate(%) in Kazakhstan in 2011?
Your answer should be compact. -11.62. What is the difference between the Net enrolment rate(%) of Low & middle income in 2007 and the Net enrolment rate(%) of Azerbaijan in 2011?
Your response must be concise. 1.51. What is the difference between the Net enrolment rate(%) in Low & middle income in 2007 and the Net enrolment rate(%) in Kazakhstan in 2011?
Offer a very short reply. 1.91. What is the difference between the Net enrolment rate(%) in Azerbaijan in 2007 and the Net enrolment rate(%) in Kazakhstan in 2011?
Your answer should be very brief. -3.6. What is the difference between the Net enrolment rate(%) in Heavily indebted poor countries in 2007 and the Net enrolment rate(%) in Low & middle income in 2012?
Your response must be concise. -13.31. What is the difference between the Net enrolment rate(%) of Heavily indebted poor countries in 2007 and the Net enrolment rate(%) of Azerbaijan in 2012?
Offer a terse response. -14.48. What is the difference between the Net enrolment rate(%) in Heavily indebted poor countries in 2007 and the Net enrolment rate(%) in Kazakhstan in 2012?
Offer a terse response. -10.31. What is the difference between the Net enrolment rate(%) of Low & middle income in 2007 and the Net enrolment rate(%) of Azerbaijan in 2012?
Make the answer very short. -0.94. What is the difference between the Net enrolment rate(%) of Low & middle income in 2007 and the Net enrolment rate(%) of Kazakhstan in 2012?
Provide a succinct answer. 3.22. What is the difference between the Net enrolment rate(%) in Azerbaijan in 2007 and the Net enrolment rate(%) in Kazakhstan in 2012?
Keep it short and to the point. -2.29. What is the difference between the Net enrolment rate(%) in Heavily indebted poor countries in 2008 and the Net enrolment rate(%) in Low & middle income in 2009?
Your response must be concise. -10.4. What is the difference between the Net enrolment rate(%) of Heavily indebted poor countries in 2008 and the Net enrolment rate(%) of Azerbaijan in 2009?
Keep it short and to the point. -7.31. What is the difference between the Net enrolment rate(%) in Heavily indebted poor countries in 2008 and the Net enrolment rate(%) in Kazakhstan in 2009?
Your response must be concise. -10.37. What is the difference between the Net enrolment rate(%) in Low & middle income in 2008 and the Net enrolment rate(%) in Azerbaijan in 2009?
Your answer should be compact. 3. What is the difference between the Net enrolment rate(%) in Low & middle income in 2008 and the Net enrolment rate(%) in Kazakhstan in 2009?
Give a very brief answer. -0.06. What is the difference between the Net enrolment rate(%) in Azerbaijan in 2008 and the Net enrolment rate(%) in Kazakhstan in 2009?
Make the answer very short. -4.77. What is the difference between the Net enrolment rate(%) of Heavily indebted poor countries in 2008 and the Net enrolment rate(%) of Low & middle income in 2010?
Your response must be concise. -10.57. What is the difference between the Net enrolment rate(%) in Heavily indebted poor countries in 2008 and the Net enrolment rate(%) in Azerbaijan in 2010?
Make the answer very short. -6.39. What is the difference between the Net enrolment rate(%) in Heavily indebted poor countries in 2008 and the Net enrolment rate(%) in Kazakhstan in 2010?
Your response must be concise. -9.23. What is the difference between the Net enrolment rate(%) of Low & middle income in 2008 and the Net enrolment rate(%) of Azerbaijan in 2010?
Keep it short and to the point. 3.92. What is the difference between the Net enrolment rate(%) of Low & middle income in 2008 and the Net enrolment rate(%) of Kazakhstan in 2010?
Give a very brief answer. 1.07. What is the difference between the Net enrolment rate(%) in Azerbaijan in 2008 and the Net enrolment rate(%) in Kazakhstan in 2010?
Make the answer very short. -3.64. What is the difference between the Net enrolment rate(%) in Heavily indebted poor countries in 2008 and the Net enrolment rate(%) in Low & middle income in 2011?
Your answer should be compact. -10.4. What is the difference between the Net enrolment rate(%) in Heavily indebted poor countries in 2008 and the Net enrolment rate(%) in Azerbaijan in 2011?
Give a very brief answer. -9.08. What is the difference between the Net enrolment rate(%) in Heavily indebted poor countries in 2008 and the Net enrolment rate(%) in Kazakhstan in 2011?
Offer a terse response. -8.68. What is the difference between the Net enrolment rate(%) of Low & middle income in 2008 and the Net enrolment rate(%) of Azerbaijan in 2011?
Make the answer very short. 1.23. What is the difference between the Net enrolment rate(%) of Low & middle income in 2008 and the Net enrolment rate(%) of Kazakhstan in 2011?
Your answer should be very brief. 1.63. What is the difference between the Net enrolment rate(%) of Azerbaijan in 2008 and the Net enrolment rate(%) of Kazakhstan in 2011?
Your answer should be compact. -3.09. What is the difference between the Net enrolment rate(%) in Heavily indebted poor countries in 2008 and the Net enrolment rate(%) in Low & middle income in 2012?
Provide a short and direct response. -10.37. What is the difference between the Net enrolment rate(%) of Heavily indebted poor countries in 2008 and the Net enrolment rate(%) of Azerbaijan in 2012?
Ensure brevity in your answer.  -11.54. What is the difference between the Net enrolment rate(%) of Heavily indebted poor countries in 2008 and the Net enrolment rate(%) of Kazakhstan in 2012?
Your answer should be compact. -7.37. What is the difference between the Net enrolment rate(%) in Low & middle income in 2008 and the Net enrolment rate(%) in Azerbaijan in 2012?
Give a very brief answer. -1.23. What is the difference between the Net enrolment rate(%) of Low & middle income in 2008 and the Net enrolment rate(%) of Kazakhstan in 2012?
Give a very brief answer. 2.94. What is the difference between the Net enrolment rate(%) in Azerbaijan in 2008 and the Net enrolment rate(%) in Kazakhstan in 2012?
Offer a very short reply. -1.77. What is the difference between the Net enrolment rate(%) of Heavily indebted poor countries in 2009 and the Net enrolment rate(%) of Low & middle income in 2010?
Provide a short and direct response. -10.46. What is the difference between the Net enrolment rate(%) of Heavily indebted poor countries in 2009 and the Net enrolment rate(%) of Azerbaijan in 2010?
Provide a short and direct response. -6.28. What is the difference between the Net enrolment rate(%) of Heavily indebted poor countries in 2009 and the Net enrolment rate(%) of Kazakhstan in 2010?
Your answer should be compact. -9.12. What is the difference between the Net enrolment rate(%) of Low & middle income in 2009 and the Net enrolment rate(%) of Azerbaijan in 2010?
Offer a terse response. 4.02. What is the difference between the Net enrolment rate(%) of Low & middle income in 2009 and the Net enrolment rate(%) of Kazakhstan in 2010?
Provide a short and direct response. 1.17. What is the difference between the Net enrolment rate(%) of Azerbaijan in 2009 and the Net enrolment rate(%) of Kazakhstan in 2010?
Offer a terse response. -1.93. What is the difference between the Net enrolment rate(%) of Heavily indebted poor countries in 2009 and the Net enrolment rate(%) of Low & middle income in 2011?
Offer a terse response. -10.29. What is the difference between the Net enrolment rate(%) in Heavily indebted poor countries in 2009 and the Net enrolment rate(%) in Azerbaijan in 2011?
Offer a terse response. -8.97. What is the difference between the Net enrolment rate(%) of Heavily indebted poor countries in 2009 and the Net enrolment rate(%) of Kazakhstan in 2011?
Provide a short and direct response. -8.57. What is the difference between the Net enrolment rate(%) of Low & middle income in 2009 and the Net enrolment rate(%) of Azerbaijan in 2011?
Give a very brief answer. 1.32. What is the difference between the Net enrolment rate(%) of Low & middle income in 2009 and the Net enrolment rate(%) of Kazakhstan in 2011?
Your answer should be compact. 1.72. What is the difference between the Net enrolment rate(%) in Azerbaijan in 2009 and the Net enrolment rate(%) in Kazakhstan in 2011?
Provide a short and direct response. -1.37. What is the difference between the Net enrolment rate(%) of Heavily indebted poor countries in 2009 and the Net enrolment rate(%) of Low & middle income in 2012?
Offer a terse response. -10.26. What is the difference between the Net enrolment rate(%) in Heavily indebted poor countries in 2009 and the Net enrolment rate(%) in Azerbaijan in 2012?
Offer a very short reply. -11.43. What is the difference between the Net enrolment rate(%) of Heavily indebted poor countries in 2009 and the Net enrolment rate(%) of Kazakhstan in 2012?
Offer a very short reply. -7.26. What is the difference between the Net enrolment rate(%) in Low & middle income in 2009 and the Net enrolment rate(%) in Azerbaijan in 2012?
Offer a terse response. -1.13. What is the difference between the Net enrolment rate(%) of Low & middle income in 2009 and the Net enrolment rate(%) of Kazakhstan in 2012?
Your answer should be compact. 3.03. What is the difference between the Net enrolment rate(%) in Azerbaijan in 2009 and the Net enrolment rate(%) in Kazakhstan in 2012?
Make the answer very short. -0.06. What is the difference between the Net enrolment rate(%) of Heavily indebted poor countries in 2010 and the Net enrolment rate(%) of Low & middle income in 2011?
Your answer should be very brief. -10.15. What is the difference between the Net enrolment rate(%) in Heavily indebted poor countries in 2010 and the Net enrolment rate(%) in Azerbaijan in 2011?
Your answer should be compact. -8.83. What is the difference between the Net enrolment rate(%) in Heavily indebted poor countries in 2010 and the Net enrolment rate(%) in Kazakhstan in 2011?
Ensure brevity in your answer.  -8.43. What is the difference between the Net enrolment rate(%) of Low & middle income in 2010 and the Net enrolment rate(%) of Azerbaijan in 2011?
Offer a very short reply. 1.49. What is the difference between the Net enrolment rate(%) in Low & middle income in 2010 and the Net enrolment rate(%) in Kazakhstan in 2011?
Ensure brevity in your answer.  1.89. What is the difference between the Net enrolment rate(%) of Azerbaijan in 2010 and the Net enrolment rate(%) of Kazakhstan in 2011?
Offer a very short reply. -2.29. What is the difference between the Net enrolment rate(%) in Heavily indebted poor countries in 2010 and the Net enrolment rate(%) in Low & middle income in 2012?
Your answer should be very brief. -10.12. What is the difference between the Net enrolment rate(%) in Heavily indebted poor countries in 2010 and the Net enrolment rate(%) in Azerbaijan in 2012?
Your answer should be compact. -11.28. What is the difference between the Net enrolment rate(%) of Heavily indebted poor countries in 2010 and the Net enrolment rate(%) of Kazakhstan in 2012?
Offer a terse response. -7.12. What is the difference between the Net enrolment rate(%) of Low & middle income in 2010 and the Net enrolment rate(%) of Azerbaijan in 2012?
Provide a short and direct response. -0.97. What is the difference between the Net enrolment rate(%) in Low & middle income in 2010 and the Net enrolment rate(%) in Kazakhstan in 2012?
Your answer should be compact. 3.2. What is the difference between the Net enrolment rate(%) in Azerbaijan in 2010 and the Net enrolment rate(%) in Kazakhstan in 2012?
Offer a terse response. -0.98. What is the difference between the Net enrolment rate(%) in Heavily indebted poor countries in 2011 and the Net enrolment rate(%) in Low & middle income in 2012?
Your answer should be compact. -9.2. What is the difference between the Net enrolment rate(%) in Heavily indebted poor countries in 2011 and the Net enrolment rate(%) in Azerbaijan in 2012?
Give a very brief answer. -10.37. What is the difference between the Net enrolment rate(%) in Heavily indebted poor countries in 2011 and the Net enrolment rate(%) in Kazakhstan in 2012?
Provide a short and direct response. -6.21. What is the difference between the Net enrolment rate(%) in Low & middle income in 2011 and the Net enrolment rate(%) in Azerbaijan in 2012?
Make the answer very short. -1.14. What is the difference between the Net enrolment rate(%) in Low & middle income in 2011 and the Net enrolment rate(%) in Kazakhstan in 2012?
Offer a very short reply. 3.03. What is the difference between the Net enrolment rate(%) of Azerbaijan in 2011 and the Net enrolment rate(%) of Kazakhstan in 2012?
Keep it short and to the point. 1.71. What is the average Net enrolment rate(%) of Heavily indebted poor countries per year?
Offer a very short reply. 77.15. What is the average Net enrolment rate(%) of Low & middle income per year?
Offer a very short reply. 88.66. What is the average Net enrolment rate(%) in Azerbaijan per year?
Your answer should be compact. 86.08. What is the average Net enrolment rate(%) of Kazakhstan per year?
Your answer should be compact. 89.04. In the year 2005, what is the difference between the Net enrolment rate(%) in Heavily indebted poor countries and Net enrolment rate(%) in Low & middle income?
Your answer should be very brief. -15.77. In the year 2005, what is the difference between the Net enrolment rate(%) in Heavily indebted poor countries and Net enrolment rate(%) in Azerbaijan?
Give a very brief answer. -14.58. In the year 2005, what is the difference between the Net enrolment rate(%) in Heavily indebted poor countries and Net enrolment rate(%) in Kazakhstan?
Your response must be concise. -19.38. In the year 2005, what is the difference between the Net enrolment rate(%) in Low & middle income and Net enrolment rate(%) in Azerbaijan?
Your answer should be compact. 1.19. In the year 2005, what is the difference between the Net enrolment rate(%) of Low & middle income and Net enrolment rate(%) of Kazakhstan?
Offer a very short reply. -3.62. In the year 2005, what is the difference between the Net enrolment rate(%) of Azerbaijan and Net enrolment rate(%) of Kazakhstan?
Keep it short and to the point. -4.81. In the year 2006, what is the difference between the Net enrolment rate(%) of Heavily indebted poor countries and Net enrolment rate(%) of Low & middle income?
Ensure brevity in your answer.  -14.04. In the year 2006, what is the difference between the Net enrolment rate(%) in Heavily indebted poor countries and Net enrolment rate(%) in Azerbaijan?
Your answer should be very brief. -12.17. In the year 2006, what is the difference between the Net enrolment rate(%) in Heavily indebted poor countries and Net enrolment rate(%) in Kazakhstan?
Make the answer very short. -16.63. In the year 2006, what is the difference between the Net enrolment rate(%) in Low & middle income and Net enrolment rate(%) in Azerbaijan?
Offer a very short reply. 1.86. In the year 2006, what is the difference between the Net enrolment rate(%) in Low & middle income and Net enrolment rate(%) in Kazakhstan?
Keep it short and to the point. -2.59. In the year 2006, what is the difference between the Net enrolment rate(%) of Azerbaijan and Net enrolment rate(%) of Kazakhstan?
Provide a succinct answer. -4.46. In the year 2007, what is the difference between the Net enrolment rate(%) of Heavily indebted poor countries and Net enrolment rate(%) of Low & middle income?
Ensure brevity in your answer.  -13.53. In the year 2007, what is the difference between the Net enrolment rate(%) in Heavily indebted poor countries and Net enrolment rate(%) in Azerbaijan?
Make the answer very short. -8.02. In the year 2007, what is the difference between the Net enrolment rate(%) in Heavily indebted poor countries and Net enrolment rate(%) in Kazakhstan?
Provide a short and direct response. -14.84. In the year 2007, what is the difference between the Net enrolment rate(%) of Low & middle income and Net enrolment rate(%) of Azerbaijan?
Provide a succinct answer. 5.51. In the year 2007, what is the difference between the Net enrolment rate(%) in Low & middle income and Net enrolment rate(%) in Kazakhstan?
Offer a terse response. -1.31. In the year 2007, what is the difference between the Net enrolment rate(%) in Azerbaijan and Net enrolment rate(%) in Kazakhstan?
Ensure brevity in your answer.  -6.82. In the year 2008, what is the difference between the Net enrolment rate(%) of Heavily indebted poor countries and Net enrolment rate(%) of Low & middle income?
Provide a short and direct response. -10.31. In the year 2008, what is the difference between the Net enrolment rate(%) in Heavily indebted poor countries and Net enrolment rate(%) in Azerbaijan?
Keep it short and to the point. -5.59. In the year 2008, what is the difference between the Net enrolment rate(%) of Heavily indebted poor countries and Net enrolment rate(%) of Kazakhstan?
Make the answer very short. -11.85. In the year 2008, what is the difference between the Net enrolment rate(%) in Low & middle income and Net enrolment rate(%) in Azerbaijan?
Your answer should be very brief. 4.71. In the year 2008, what is the difference between the Net enrolment rate(%) in Low & middle income and Net enrolment rate(%) in Kazakhstan?
Ensure brevity in your answer.  -1.55. In the year 2008, what is the difference between the Net enrolment rate(%) of Azerbaijan and Net enrolment rate(%) of Kazakhstan?
Provide a succinct answer. -6.26. In the year 2009, what is the difference between the Net enrolment rate(%) in Heavily indebted poor countries and Net enrolment rate(%) in Low & middle income?
Your answer should be compact. -10.29. In the year 2009, what is the difference between the Net enrolment rate(%) in Heavily indebted poor countries and Net enrolment rate(%) in Azerbaijan?
Give a very brief answer. -7.2. In the year 2009, what is the difference between the Net enrolment rate(%) in Heavily indebted poor countries and Net enrolment rate(%) in Kazakhstan?
Your answer should be compact. -10.26. In the year 2009, what is the difference between the Net enrolment rate(%) of Low & middle income and Net enrolment rate(%) of Azerbaijan?
Your answer should be very brief. 3.09. In the year 2009, what is the difference between the Net enrolment rate(%) of Low & middle income and Net enrolment rate(%) of Kazakhstan?
Provide a succinct answer. 0.04. In the year 2009, what is the difference between the Net enrolment rate(%) of Azerbaijan and Net enrolment rate(%) of Kazakhstan?
Keep it short and to the point. -3.06. In the year 2010, what is the difference between the Net enrolment rate(%) of Heavily indebted poor countries and Net enrolment rate(%) of Low & middle income?
Keep it short and to the point. -10.32. In the year 2010, what is the difference between the Net enrolment rate(%) of Heavily indebted poor countries and Net enrolment rate(%) of Azerbaijan?
Your answer should be very brief. -6.13. In the year 2010, what is the difference between the Net enrolment rate(%) in Heavily indebted poor countries and Net enrolment rate(%) in Kazakhstan?
Your response must be concise. -8.98. In the year 2010, what is the difference between the Net enrolment rate(%) of Low & middle income and Net enrolment rate(%) of Azerbaijan?
Offer a very short reply. 4.18. In the year 2010, what is the difference between the Net enrolment rate(%) in Low & middle income and Net enrolment rate(%) in Kazakhstan?
Your response must be concise. 1.34. In the year 2010, what is the difference between the Net enrolment rate(%) in Azerbaijan and Net enrolment rate(%) in Kazakhstan?
Keep it short and to the point. -2.85. In the year 2011, what is the difference between the Net enrolment rate(%) of Heavily indebted poor countries and Net enrolment rate(%) of Low & middle income?
Offer a very short reply. -9.23. In the year 2011, what is the difference between the Net enrolment rate(%) of Heavily indebted poor countries and Net enrolment rate(%) of Azerbaijan?
Your answer should be very brief. -7.92. In the year 2011, what is the difference between the Net enrolment rate(%) of Heavily indebted poor countries and Net enrolment rate(%) of Kazakhstan?
Provide a succinct answer. -7.52. In the year 2011, what is the difference between the Net enrolment rate(%) of Low & middle income and Net enrolment rate(%) of Azerbaijan?
Keep it short and to the point. 1.32. In the year 2011, what is the difference between the Net enrolment rate(%) of Low & middle income and Net enrolment rate(%) of Kazakhstan?
Provide a short and direct response. 1.72. In the year 2011, what is the difference between the Net enrolment rate(%) in Azerbaijan and Net enrolment rate(%) in Kazakhstan?
Offer a terse response. 0.4. In the year 2012, what is the difference between the Net enrolment rate(%) in Heavily indebted poor countries and Net enrolment rate(%) in Low & middle income?
Offer a very short reply. -8.61. In the year 2012, what is the difference between the Net enrolment rate(%) of Heavily indebted poor countries and Net enrolment rate(%) of Azerbaijan?
Ensure brevity in your answer.  -9.78. In the year 2012, what is the difference between the Net enrolment rate(%) in Heavily indebted poor countries and Net enrolment rate(%) in Kazakhstan?
Give a very brief answer. -5.61. In the year 2012, what is the difference between the Net enrolment rate(%) of Low & middle income and Net enrolment rate(%) of Azerbaijan?
Your answer should be very brief. -1.17. In the year 2012, what is the difference between the Net enrolment rate(%) of Low & middle income and Net enrolment rate(%) of Kazakhstan?
Provide a succinct answer. 3. In the year 2012, what is the difference between the Net enrolment rate(%) of Azerbaijan and Net enrolment rate(%) of Kazakhstan?
Your answer should be very brief. 4.17. What is the ratio of the Net enrolment rate(%) in Heavily indebted poor countries in 2005 to that in 2006?
Your answer should be very brief. 0.97. What is the ratio of the Net enrolment rate(%) in Kazakhstan in 2005 to that in 2006?
Provide a short and direct response. 1.01. What is the ratio of the Net enrolment rate(%) in Heavily indebted poor countries in 2005 to that in 2007?
Your answer should be compact. 0.95. What is the ratio of the Net enrolment rate(%) in Low & middle income in 2005 to that in 2007?
Your answer should be compact. 0.98. What is the ratio of the Net enrolment rate(%) in Azerbaijan in 2005 to that in 2007?
Your response must be concise. 1.03. What is the ratio of the Net enrolment rate(%) of Kazakhstan in 2005 to that in 2007?
Provide a succinct answer. 1.01. What is the ratio of the Net enrolment rate(%) in Heavily indebted poor countries in 2005 to that in 2008?
Give a very brief answer. 0.91. What is the ratio of the Net enrolment rate(%) in Low & middle income in 2005 to that in 2008?
Make the answer very short. 0.98. What is the ratio of the Net enrolment rate(%) in Azerbaijan in 2005 to that in 2008?
Keep it short and to the point. 1.02. What is the ratio of the Net enrolment rate(%) in Heavily indebted poor countries in 2005 to that in 2009?
Ensure brevity in your answer.  0.91. What is the ratio of the Net enrolment rate(%) of Low & middle income in 2005 to that in 2009?
Keep it short and to the point. 0.98. What is the ratio of the Net enrolment rate(%) in Kazakhstan in 2005 to that in 2009?
Your answer should be very brief. 1.02. What is the ratio of the Net enrolment rate(%) in Heavily indebted poor countries in 2005 to that in 2010?
Provide a succinct answer. 0.91. What is the ratio of the Net enrolment rate(%) of Low & middle income in 2005 to that in 2010?
Make the answer very short. 0.98. What is the ratio of the Net enrolment rate(%) of Azerbaijan in 2005 to that in 2010?
Give a very brief answer. 1.01. What is the ratio of the Net enrolment rate(%) in Kazakhstan in 2005 to that in 2010?
Keep it short and to the point. 1.04. What is the ratio of the Net enrolment rate(%) of Heavily indebted poor countries in 2005 to that in 2011?
Keep it short and to the point. 0.9. What is the ratio of the Net enrolment rate(%) in Low & middle income in 2005 to that in 2011?
Your response must be concise. 0.98. What is the ratio of the Net enrolment rate(%) of Azerbaijan in 2005 to that in 2011?
Provide a succinct answer. 0.98. What is the ratio of the Net enrolment rate(%) in Kazakhstan in 2005 to that in 2011?
Offer a very short reply. 1.04. What is the ratio of the Net enrolment rate(%) of Heavily indebted poor countries in 2005 to that in 2012?
Make the answer very short. 0.89. What is the ratio of the Net enrolment rate(%) in Low & middle income in 2005 to that in 2012?
Ensure brevity in your answer.  0.98. What is the ratio of the Net enrolment rate(%) in Azerbaijan in 2005 to that in 2012?
Ensure brevity in your answer.  0.96. What is the ratio of the Net enrolment rate(%) in Kazakhstan in 2005 to that in 2012?
Offer a terse response. 1.06. What is the ratio of the Net enrolment rate(%) of Heavily indebted poor countries in 2006 to that in 2007?
Ensure brevity in your answer.  0.97. What is the ratio of the Net enrolment rate(%) in Low & middle income in 2006 to that in 2007?
Your answer should be compact. 0.98. What is the ratio of the Net enrolment rate(%) in Azerbaijan in 2006 to that in 2007?
Give a very brief answer. 1.03. What is the ratio of the Net enrolment rate(%) of Kazakhstan in 2006 to that in 2007?
Offer a very short reply. 1. What is the ratio of the Net enrolment rate(%) in Heavily indebted poor countries in 2006 to that in 2008?
Give a very brief answer. 0.94. What is the ratio of the Net enrolment rate(%) in Low & middle income in 2006 to that in 2008?
Provide a short and direct response. 0.99. What is the ratio of the Net enrolment rate(%) of Azerbaijan in 2006 to that in 2008?
Ensure brevity in your answer.  1.02. What is the ratio of the Net enrolment rate(%) of Heavily indebted poor countries in 2006 to that in 2009?
Offer a terse response. 0.94. What is the ratio of the Net enrolment rate(%) in Low & middle income in 2006 to that in 2009?
Your answer should be very brief. 0.99. What is the ratio of the Net enrolment rate(%) in Kazakhstan in 2006 to that in 2009?
Give a very brief answer. 1.02. What is the ratio of the Net enrolment rate(%) of Heavily indebted poor countries in 2006 to that in 2010?
Provide a succinct answer. 0.94. What is the ratio of the Net enrolment rate(%) in Low & middle income in 2006 to that in 2010?
Ensure brevity in your answer.  0.98. What is the ratio of the Net enrolment rate(%) of Azerbaijan in 2006 to that in 2010?
Your response must be concise. 1.01. What is the ratio of the Net enrolment rate(%) in Kazakhstan in 2006 to that in 2010?
Provide a short and direct response. 1.03. What is the ratio of the Net enrolment rate(%) in Heavily indebted poor countries in 2006 to that in 2011?
Provide a succinct answer. 0.92. What is the ratio of the Net enrolment rate(%) in Low & middle income in 2006 to that in 2011?
Provide a succinct answer. 0.99. What is the ratio of the Net enrolment rate(%) in Azerbaijan in 2006 to that in 2011?
Make the answer very short. 0.98. What is the ratio of the Net enrolment rate(%) of Kazakhstan in 2006 to that in 2011?
Make the answer very short. 1.04. What is the ratio of the Net enrolment rate(%) in Heavily indebted poor countries in 2006 to that in 2012?
Your answer should be very brief. 0.92. What is the ratio of the Net enrolment rate(%) of Low & middle income in 2006 to that in 2012?
Provide a succinct answer. 0.99. What is the ratio of the Net enrolment rate(%) of Azerbaijan in 2006 to that in 2012?
Make the answer very short. 0.95. What is the ratio of the Net enrolment rate(%) in Kazakhstan in 2006 to that in 2012?
Your answer should be compact. 1.05. What is the ratio of the Net enrolment rate(%) in Heavily indebted poor countries in 2007 to that in 2008?
Provide a short and direct response. 0.96. What is the ratio of the Net enrolment rate(%) of Low & middle income in 2007 to that in 2008?
Ensure brevity in your answer.  1. What is the ratio of the Net enrolment rate(%) of Azerbaijan in 2007 to that in 2008?
Offer a very short reply. 0.99. What is the ratio of the Net enrolment rate(%) of Heavily indebted poor countries in 2007 to that in 2009?
Offer a very short reply. 0.96. What is the ratio of the Net enrolment rate(%) of Azerbaijan in 2007 to that in 2009?
Make the answer very short. 0.97. What is the ratio of the Net enrolment rate(%) of Kazakhstan in 2007 to that in 2009?
Give a very brief answer. 1.02. What is the ratio of the Net enrolment rate(%) of Heavily indebted poor countries in 2007 to that in 2010?
Offer a very short reply. 0.96. What is the ratio of the Net enrolment rate(%) of Low & middle income in 2007 to that in 2010?
Make the answer very short. 1. What is the ratio of the Net enrolment rate(%) of Azerbaijan in 2007 to that in 2010?
Your response must be concise. 0.98. What is the ratio of the Net enrolment rate(%) in Kazakhstan in 2007 to that in 2010?
Provide a succinct answer. 1.03. What is the ratio of the Net enrolment rate(%) in Heavily indebted poor countries in 2007 to that in 2011?
Your response must be concise. 0.95. What is the ratio of the Net enrolment rate(%) of Low & middle income in 2007 to that in 2011?
Make the answer very short. 1. What is the ratio of the Net enrolment rate(%) in Azerbaijan in 2007 to that in 2011?
Your response must be concise. 0.95. What is the ratio of the Net enrolment rate(%) of Kazakhstan in 2007 to that in 2011?
Provide a succinct answer. 1.04. What is the ratio of the Net enrolment rate(%) of Heavily indebted poor countries in 2007 to that in 2012?
Your response must be concise. 0.94. What is the ratio of the Net enrolment rate(%) of Low & middle income in 2007 to that in 2012?
Provide a succinct answer. 1. What is the ratio of the Net enrolment rate(%) of Azerbaijan in 2007 to that in 2012?
Offer a very short reply. 0.93. What is the ratio of the Net enrolment rate(%) of Kazakhstan in 2007 to that in 2012?
Give a very brief answer. 1.05. What is the ratio of the Net enrolment rate(%) in Low & middle income in 2008 to that in 2009?
Provide a short and direct response. 1. What is the ratio of the Net enrolment rate(%) in Azerbaijan in 2008 to that in 2009?
Make the answer very short. 0.98. What is the ratio of the Net enrolment rate(%) of Kazakhstan in 2008 to that in 2009?
Your answer should be compact. 1.02. What is the ratio of the Net enrolment rate(%) in Kazakhstan in 2008 to that in 2010?
Provide a succinct answer. 1.03. What is the ratio of the Net enrolment rate(%) in Heavily indebted poor countries in 2008 to that in 2011?
Keep it short and to the point. 0.99. What is the ratio of the Net enrolment rate(%) in Low & middle income in 2008 to that in 2011?
Your answer should be very brief. 1. What is the ratio of the Net enrolment rate(%) in Azerbaijan in 2008 to that in 2011?
Offer a terse response. 0.96. What is the ratio of the Net enrolment rate(%) of Kazakhstan in 2008 to that in 2011?
Your answer should be compact. 1.04. What is the ratio of the Net enrolment rate(%) of Heavily indebted poor countries in 2008 to that in 2012?
Provide a succinct answer. 0.98. What is the ratio of the Net enrolment rate(%) in Low & middle income in 2008 to that in 2012?
Ensure brevity in your answer.  1. What is the ratio of the Net enrolment rate(%) in Azerbaijan in 2008 to that in 2012?
Your answer should be compact. 0.93. What is the ratio of the Net enrolment rate(%) of Kazakhstan in 2008 to that in 2012?
Ensure brevity in your answer.  1.05. What is the ratio of the Net enrolment rate(%) in Heavily indebted poor countries in 2009 to that in 2010?
Your answer should be compact. 1. What is the ratio of the Net enrolment rate(%) of Azerbaijan in 2009 to that in 2010?
Keep it short and to the point. 1.01. What is the ratio of the Net enrolment rate(%) in Kazakhstan in 2009 to that in 2010?
Your answer should be compact. 1.01. What is the ratio of the Net enrolment rate(%) in Azerbaijan in 2009 to that in 2011?
Your answer should be compact. 0.98. What is the ratio of the Net enrolment rate(%) in Kazakhstan in 2009 to that in 2011?
Provide a short and direct response. 1.02. What is the ratio of the Net enrolment rate(%) in Heavily indebted poor countries in 2009 to that in 2012?
Offer a very short reply. 0.98. What is the ratio of the Net enrolment rate(%) of Azerbaijan in 2009 to that in 2012?
Make the answer very short. 0.95. What is the ratio of the Net enrolment rate(%) of Kazakhstan in 2009 to that in 2012?
Keep it short and to the point. 1.03. What is the ratio of the Net enrolment rate(%) of Azerbaijan in 2010 to that in 2011?
Your response must be concise. 0.97. What is the ratio of the Net enrolment rate(%) of Kazakhstan in 2010 to that in 2011?
Ensure brevity in your answer.  1.01. What is the ratio of the Net enrolment rate(%) of Heavily indebted poor countries in 2010 to that in 2012?
Your answer should be very brief. 0.98. What is the ratio of the Net enrolment rate(%) in Azerbaijan in 2010 to that in 2012?
Your answer should be very brief. 0.94. What is the ratio of the Net enrolment rate(%) in Kazakhstan in 2010 to that in 2012?
Give a very brief answer. 1.02. What is the ratio of the Net enrolment rate(%) in Low & middle income in 2011 to that in 2012?
Offer a terse response. 1. What is the ratio of the Net enrolment rate(%) of Azerbaijan in 2011 to that in 2012?
Your answer should be compact. 0.97. What is the ratio of the Net enrolment rate(%) in Kazakhstan in 2011 to that in 2012?
Keep it short and to the point. 1.02. What is the difference between the highest and the second highest Net enrolment rate(%) of Heavily indebted poor countries?
Make the answer very short. 0.6. What is the difference between the highest and the second highest Net enrolment rate(%) in Low & middle income?
Provide a succinct answer. 0.02. What is the difference between the highest and the second highest Net enrolment rate(%) in Azerbaijan?
Provide a succinct answer. 2.46. What is the difference between the highest and the second highest Net enrolment rate(%) of Kazakhstan?
Ensure brevity in your answer.  0.54. What is the difference between the highest and the lowest Net enrolment rate(%) in Heavily indebted poor countries?
Keep it short and to the point. 8.7. What is the difference between the highest and the lowest Net enrolment rate(%) of Low & middle income?
Provide a short and direct response. 1.77. What is the difference between the highest and the lowest Net enrolment rate(%) in Azerbaijan?
Your answer should be compact. 6.46. What is the difference between the highest and the lowest Net enrolment rate(%) of Kazakhstan?
Offer a very short reply. 5.07. 